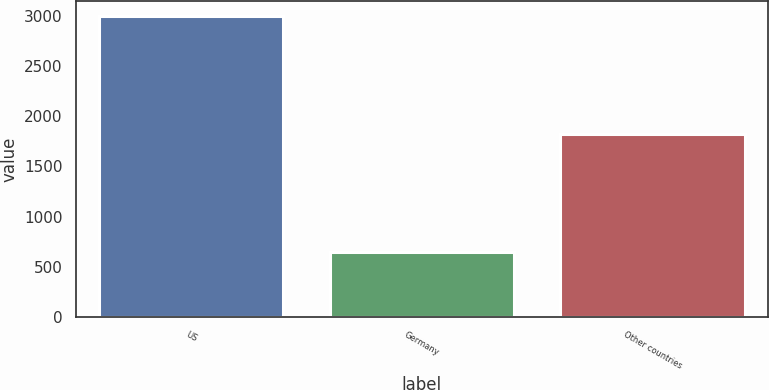<chart> <loc_0><loc_0><loc_500><loc_500><bar_chart><fcel>US<fcel>Germany<fcel>Other countries<nl><fcel>2997<fcel>647<fcel>1823<nl></chart> 